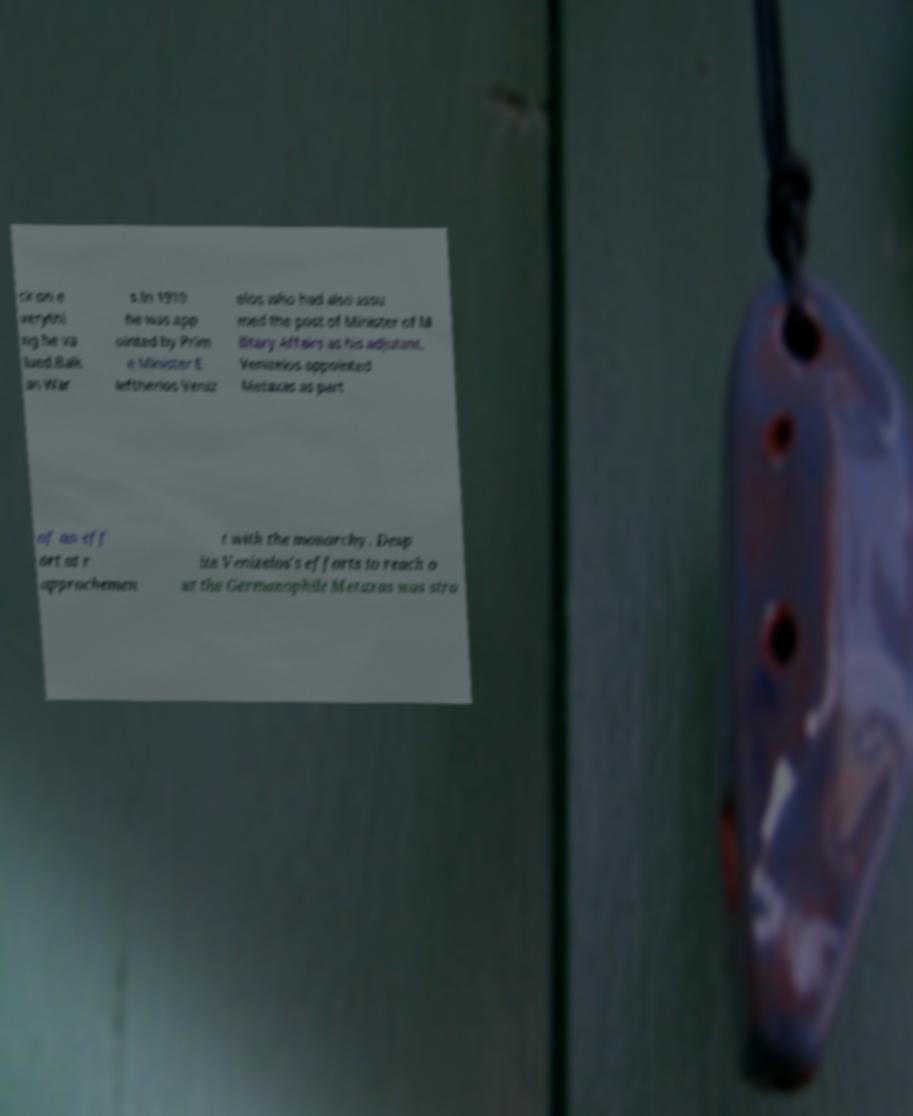Please identify and transcribe the text found in this image. ck on e verythi ng he va lued.Balk an War s.In 1910 he was app ointed by Prim e Minister E leftherios Veniz elos who had also assu med the post of Minister of M ilitary Affairs as his adjutant. Venizelos appointed Metaxas as part of an eff ort at r approchemen t with the monarchy. Desp ite Venizelos's efforts to reach o ut the Germanophile Metaxas was stro 